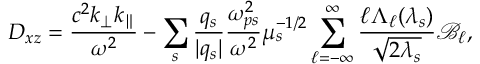Convert formula to latex. <formula><loc_0><loc_0><loc_500><loc_500>D _ { x z } = \frac { c ^ { 2 } k _ { \perp } k _ { \| } } { \omega ^ { 2 } } - \sum _ { s } \frac { q _ { s } } { | q _ { s } | } \frac { \omega _ { p s } ^ { 2 } } { \omega ^ { 2 } } \mu _ { s } ^ { - 1 / 2 } \sum _ { \ell = - \infty } ^ { \infty } \frac { \ell \Lambda _ { \ell } ( \lambda _ { s } ) } { \sqrt { 2 \lambda _ { s } } } \mathcal { B } _ { \ell } ,</formula> 